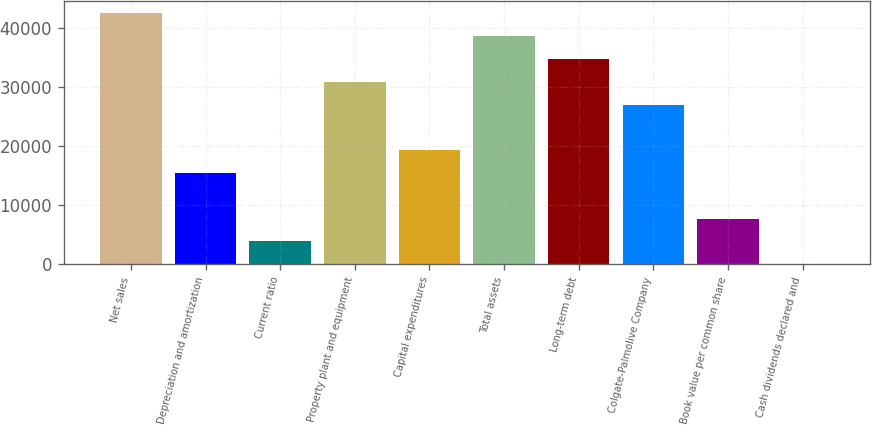Convert chart to OTSL. <chart><loc_0><loc_0><loc_500><loc_500><bar_chart><fcel>Net sales<fcel>Depreciation and amortization<fcel>Current ratio<fcel>Property plant and equipment<fcel>Capital expenditures<fcel>Total assets<fcel>Long-term debt<fcel>Colgate-Palmolive Company<fcel>Book value per common share<fcel>Cash dividends declared and<nl><fcel>42459.9<fcel>15440.7<fcel>3861.03<fcel>30880.3<fcel>19300.6<fcel>38600<fcel>34740.2<fcel>27020.4<fcel>7720.92<fcel>1.14<nl></chart> 